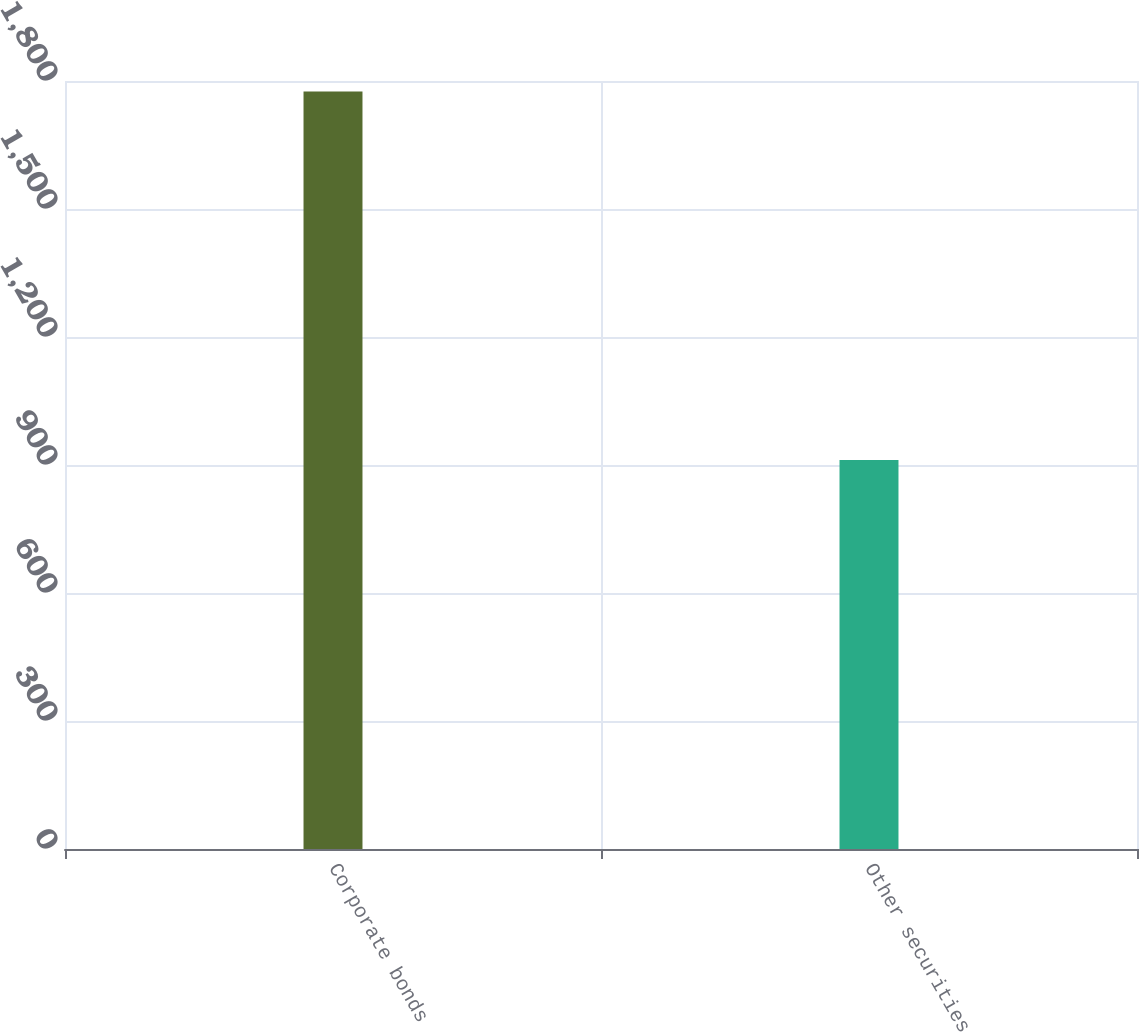<chart> <loc_0><loc_0><loc_500><loc_500><bar_chart><fcel>Corporate bonds<fcel>Other securities<nl><fcel>1775.6<fcel>911.5<nl></chart> 